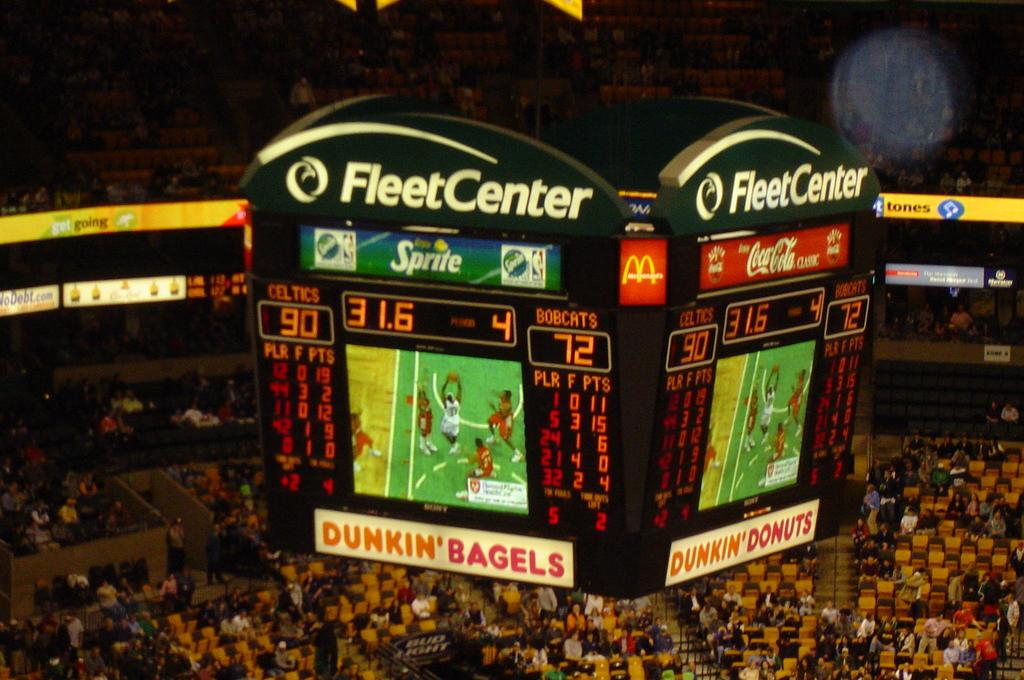<image>
Provide a brief description of the given image. the scoreboard from the fleetcenter sponsored by dunkin donuts 